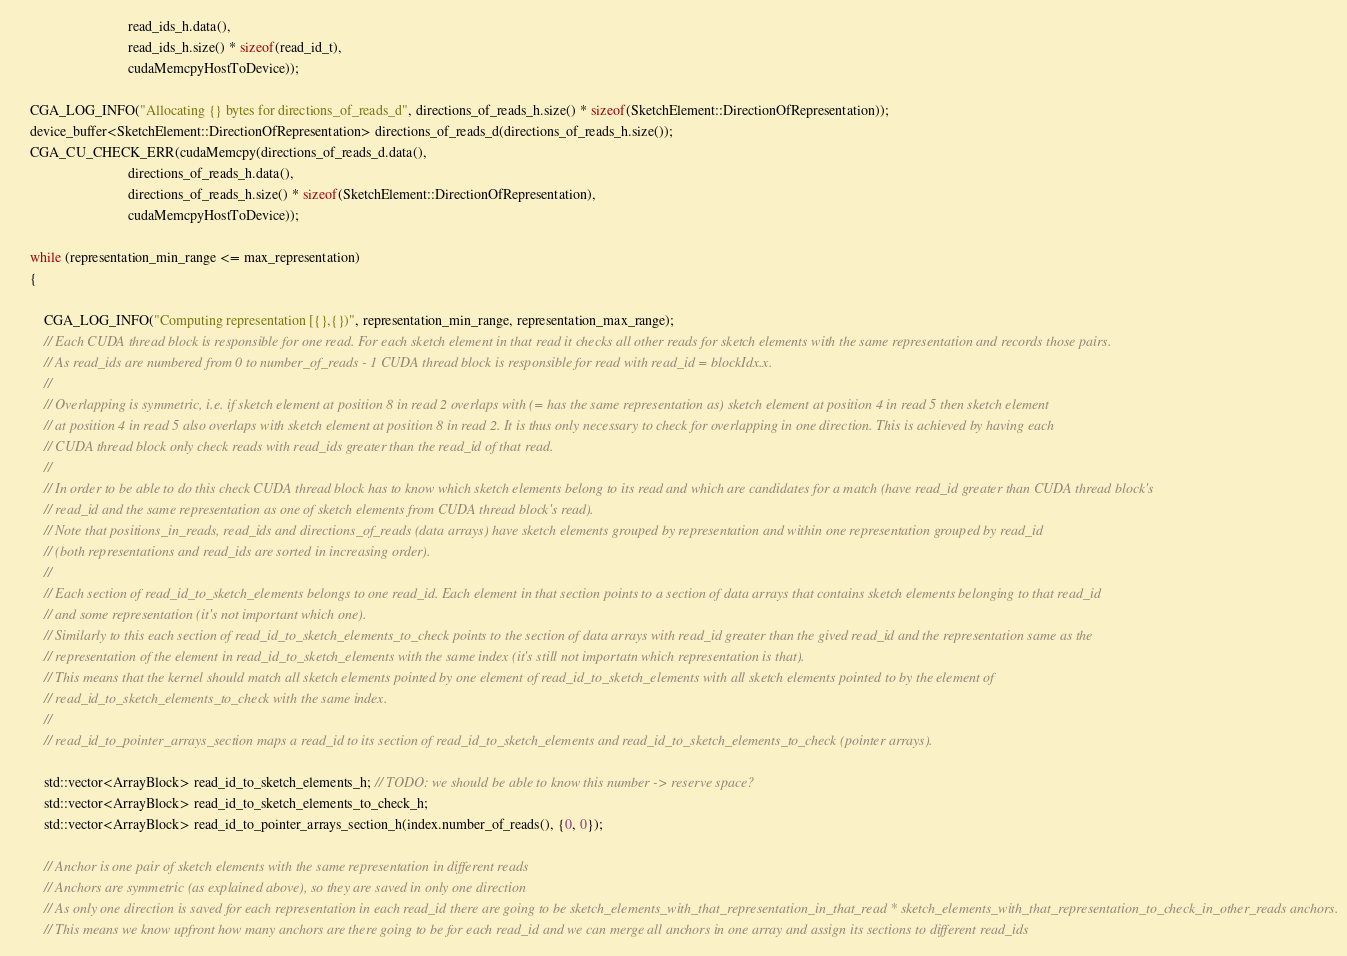<code> <loc_0><loc_0><loc_500><loc_500><_Cuda_>                                read_ids_h.data(),
                                read_ids_h.size() * sizeof(read_id_t),
                                cudaMemcpyHostToDevice));

    CGA_LOG_INFO("Allocating {} bytes for directions_of_reads_d", directions_of_reads_h.size() * sizeof(SketchElement::DirectionOfRepresentation));
    device_buffer<SketchElement::DirectionOfRepresentation> directions_of_reads_d(directions_of_reads_h.size());
    CGA_CU_CHECK_ERR(cudaMemcpy(directions_of_reads_d.data(),
                                directions_of_reads_h.data(),
                                directions_of_reads_h.size() * sizeof(SketchElement::DirectionOfRepresentation),
                                cudaMemcpyHostToDevice));

    while (representation_min_range <= max_representation)
    {

        CGA_LOG_INFO("Computing representation [{},{})", representation_min_range, representation_max_range);
        // Each CUDA thread block is responsible for one read. For each sketch element in that read it checks all other reads for sketch elements with the same representation and records those pairs.
        // As read_ids are numbered from 0 to number_of_reads - 1 CUDA thread block is responsible for read with read_id = blockIdx.x.
        //
        // Overlapping is symmetric, i.e. if sketch element at position 8 in read 2 overlaps with (= has the same representation as) sketch element at position 4 in read 5 then sketch element
        // at position 4 in read 5 also overlaps with sketch element at position 8 in read 2. It is thus only necessary to check for overlapping in one direction. This is achieved by having each
        // CUDA thread block only check reads with read_ids greater than the read_id of that read.
        //
        // In order to be able to do this check CUDA thread block has to know which sketch elements belong to its read and which are candidates for a match (have read_id greater than CUDA thread block's
        // read_id and the same representation as one of sketch elements from CUDA thread block's read).
        // Note that positions_in_reads, read_ids and directions_of_reads (data arrays) have sketch elements grouped by representation and within one representation grouped by read_id
        // (both representations and read_ids are sorted in increasing order).
        //
        // Each section of read_id_to_sketch_elements belongs to one read_id. Each element in that section points to a section of data arrays that contains sketch elements belonging to that read_id
        // and some representation (it's not important which one).
        // Similarly to this each section of read_id_to_sketch_elements_to_check points to the section of data arrays with read_id greater than the gived read_id and the representation same as the
        // representation of the element in read_id_to_sketch_elements with the same index (it's still not importatn which representation is that).
        // This means that the kernel should match all sketch elements pointed by one element of read_id_to_sketch_elements with all sketch elements pointed to by the element of
        // read_id_to_sketch_elements_to_check with the same index.
        //
        // read_id_to_pointer_arrays_section maps a read_id to its section of read_id_to_sketch_elements and read_id_to_sketch_elements_to_check (pointer arrays).

        std::vector<ArrayBlock> read_id_to_sketch_elements_h; // TODO: we should be able to know this number -> reserve space?
        std::vector<ArrayBlock> read_id_to_sketch_elements_to_check_h;
        std::vector<ArrayBlock> read_id_to_pointer_arrays_section_h(index.number_of_reads(), {0, 0});

        // Anchor is one pair of sketch elements with the same representation in different reads
        // Anchors are symmetric (as explained above), so they are saved in only one direction
        // As only one direction is saved for each representation in each read_id there are going to be sketch_elements_with_that_representation_in_that_read * sketch_elements_with_that_representation_to_check_in_other_reads anchors.
        // This means we know upfront how many anchors are there going to be for each read_id and we can merge all anchors in one array and assign its sections to different read_ids</code> 